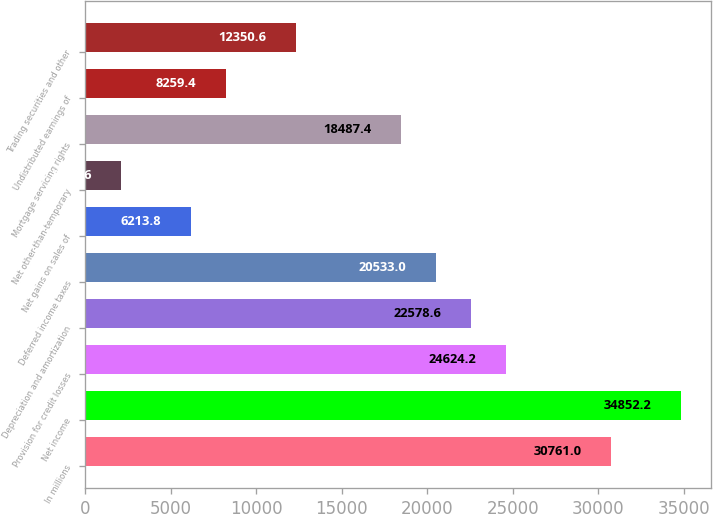<chart> <loc_0><loc_0><loc_500><loc_500><bar_chart><fcel>In millions<fcel>Net income<fcel>Provision for credit losses<fcel>Depreciation and amortization<fcel>Deferred income taxes<fcel>Net gains on sales of<fcel>Net other-than-temporary<fcel>Mortgage servicing rights<fcel>Undistributed earnings of<fcel>Trading securities and other<nl><fcel>30761<fcel>34852.2<fcel>24624.2<fcel>22578.6<fcel>20533<fcel>6213.8<fcel>2122.6<fcel>18487.4<fcel>8259.4<fcel>12350.6<nl></chart> 